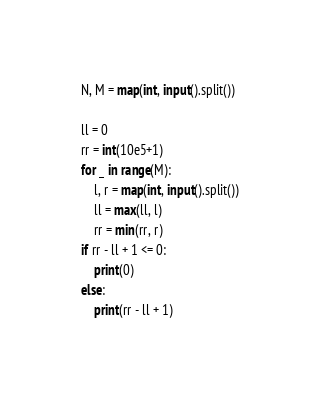Convert code to text. <code><loc_0><loc_0><loc_500><loc_500><_Python_>N, M = map(int, input().split())

ll = 0
rr = int(10e5+1)
for _ in range(M):
    l, r = map(int, input().split())
    ll = max(ll, l)
    rr = min(rr, r)
if rr - ll + 1 <= 0:
    print(0)
else:
    print(rr - ll + 1)</code> 